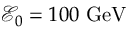<formula> <loc_0><loc_0><loc_500><loc_500>\mathcal { E } _ { 0 } = 1 0 0 \ G e V</formula> 